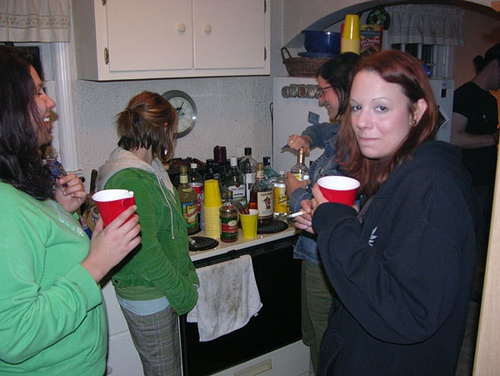Describe the objects in this image and their specific colors. I can see people in gray, black, maroon, lightpink, and darkgray tones, people in gray, turquoise, black, and teal tones, people in gray, darkgreen, and black tones, oven in gray, black, and darkgray tones, and people in gray, black, tan, and olive tones in this image. 